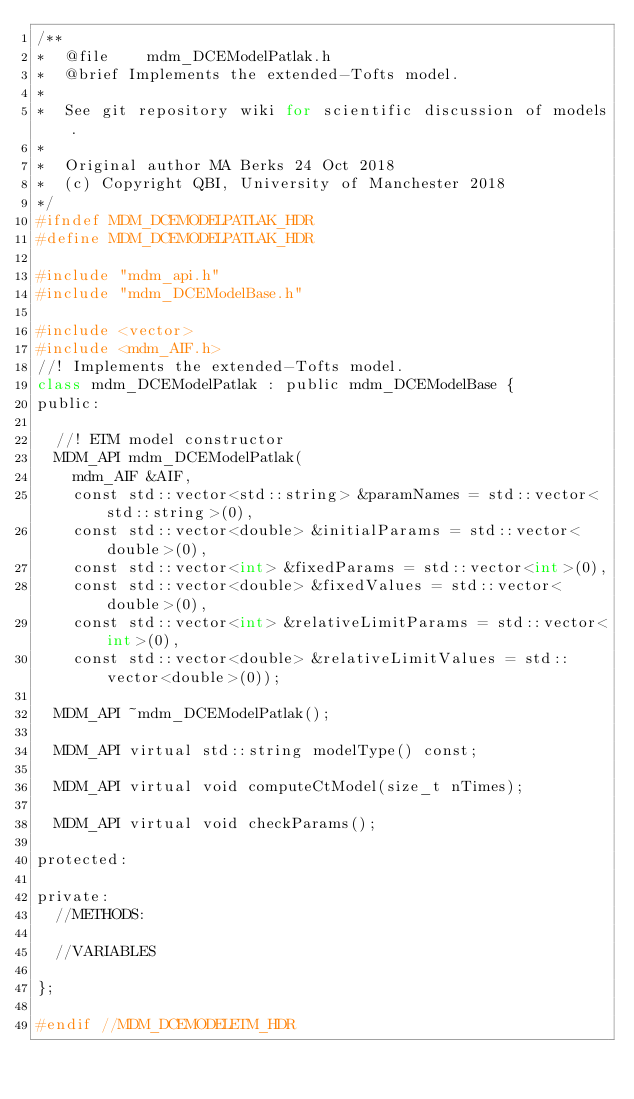<code> <loc_0><loc_0><loc_500><loc_500><_Python_>/**
*  @file    mdm_DCEModelPatlak.h
*  @brief Implements the extended-Tofts model.
*
*	 See git repository wiki for scientific discussion of models.
*
*  Original author MA Berks 24 Oct 2018
*  (c) Copyright QBI, University of Manchester 2018
*/
#ifndef MDM_DCEMODELPATLAK_HDR
#define MDM_DCEMODELPATLAK_HDR

#include "mdm_api.h"
#include "mdm_DCEModelBase.h"

#include <vector>
#include <mdm_AIF.h>
//! Implements the extended-Tofts model.
class mdm_DCEModelPatlak : public mdm_DCEModelBase {
public:
	
  //! ETM model constructor
  MDM_API mdm_DCEModelPatlak(
    mdm_AIF &AIF,
    const std::vector<std::string> &paramNames = std::vector<std::string>(0),
    const std::vector<double> &initialParams = std::vector<double>(0),
    const std::vector<int> &fixedParams = std::vector<int>(0),
    const std::vector<double> &fixedValues = std::vector<double>(0),
		const std::vector<int> &relativeLimitParams = std::vector<int>(0),
		const std::vector<double> &relativeLimitValues = std::vector<double>(0));

  MDM_API ~mdm_DCEModelPatlak();

  MDM_API virtual std::string modelType() const;

  MDM_API virtual void computeCtModel(size_t nTimes);

  MDM_API virtual void checkParams();

protected:

private:
  //METHODS:

  //VARIABLES
	
};

#endif //MDM_DCEMODELETM_HDR
</code> 